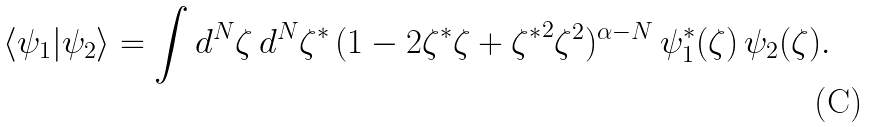Convert formula to latex. <formula><loc_0><loc_0><loc_500><loc_500>\langle \psi _ { 1 } | \psi _ { 2 } \rangle = \int d ^ { N } \zeta \, d ^ { N } \zeta ^ { * } \, ( 1 - 2 \zeta ^ { * } \zeta + { \zeta ^ { * } } ^ { 2 } \zeta ^ { 2 } ) ^ { \alpha - N } \, \psi _ { 1 } ^ { * } ( \zeta ) \, \psi _ { 2 } ( \zeta ) .</formula> 